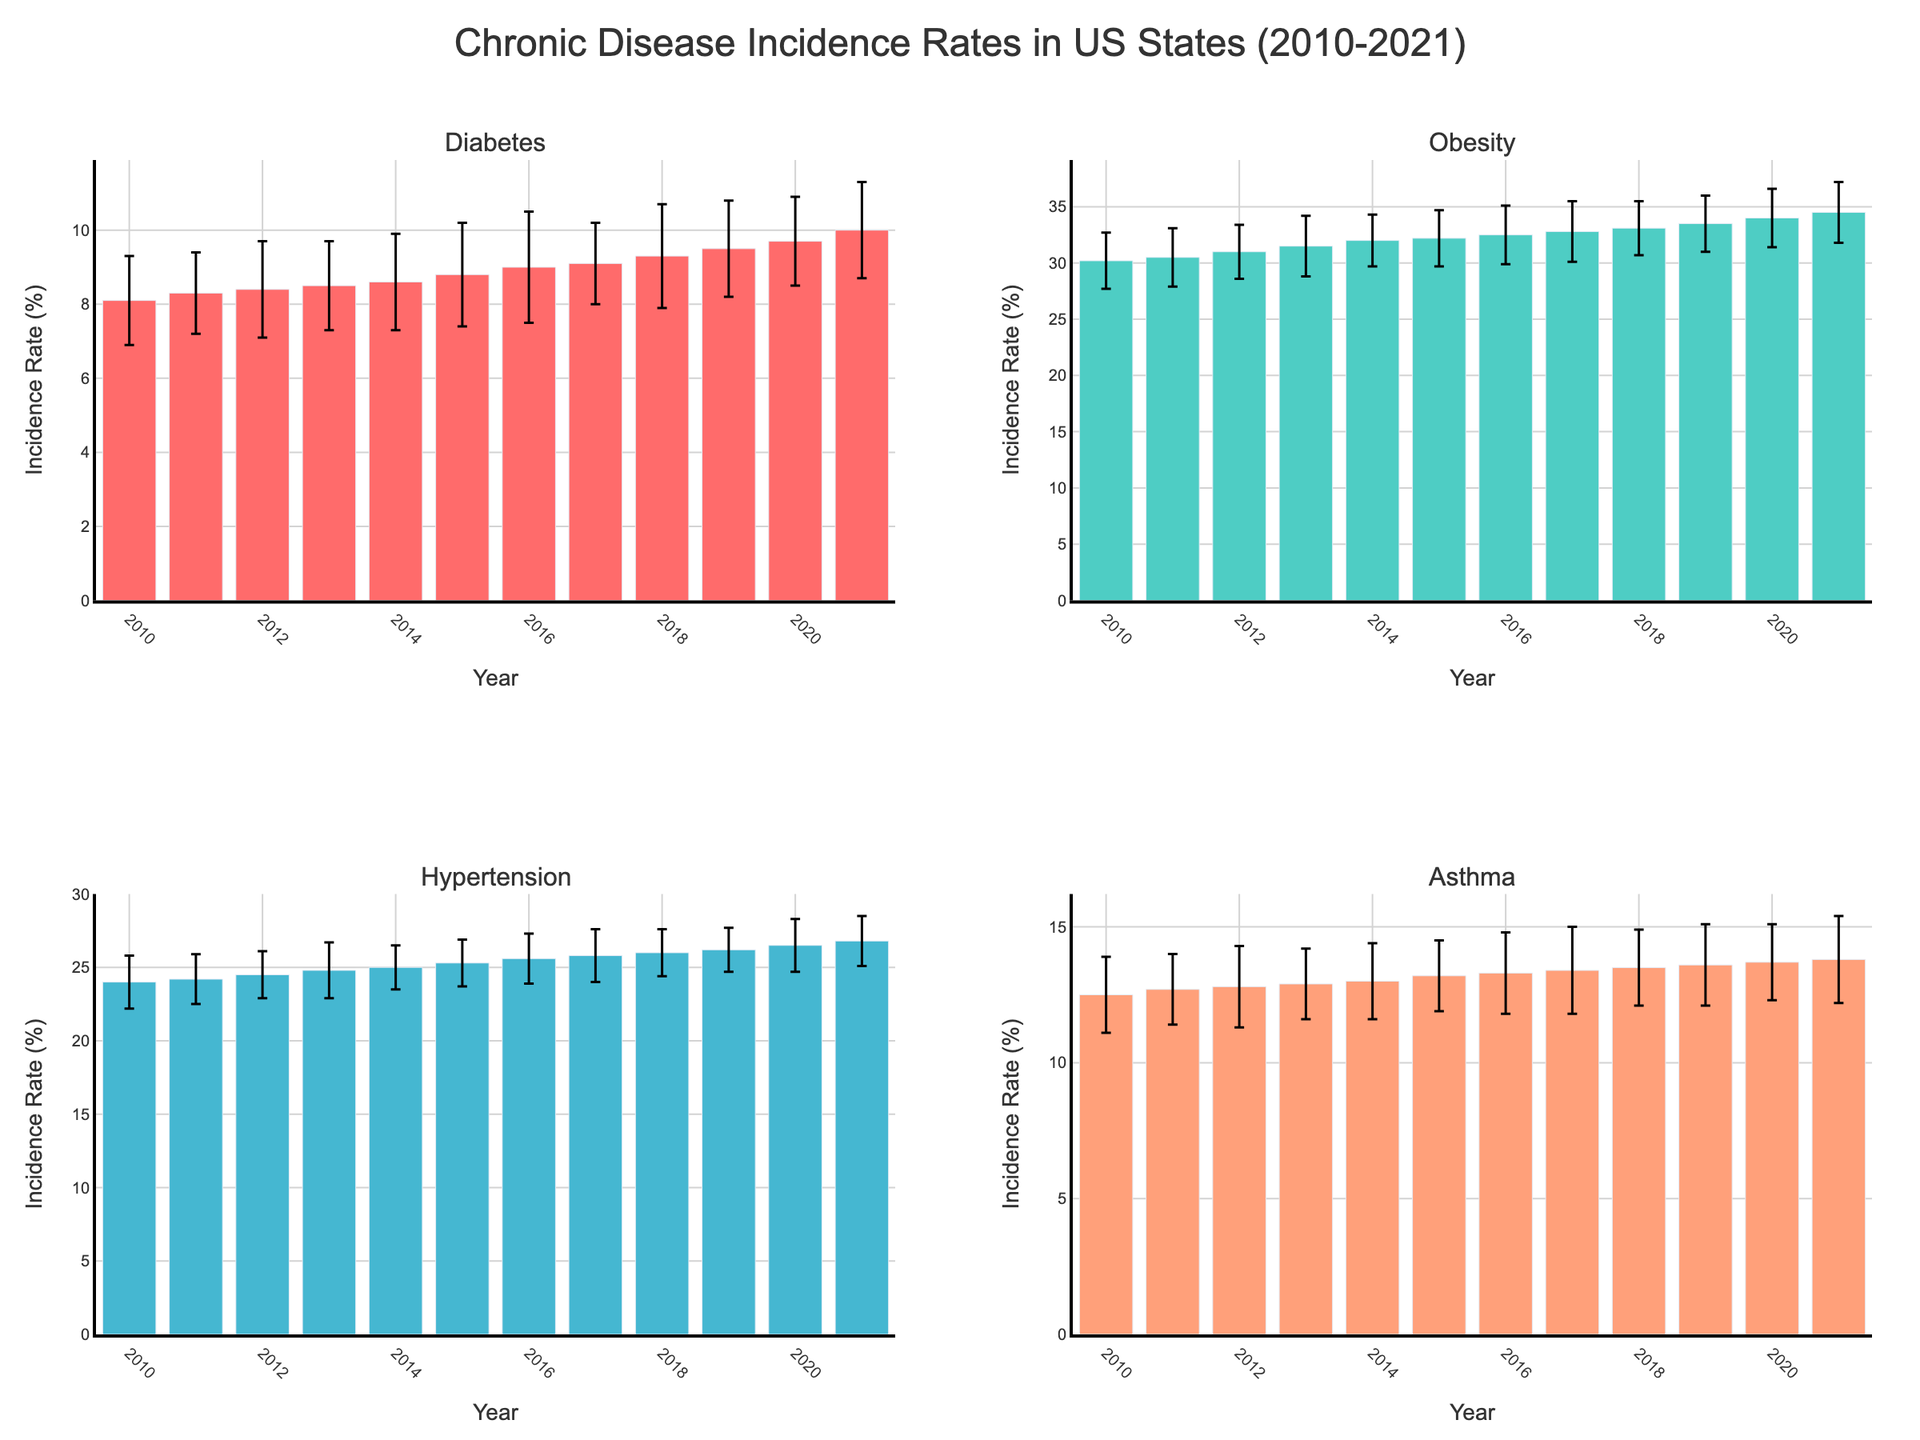What are the chronic diseases shown in the figure? The subplot titles mention Diabetes, Obesity, Hypertension, and Asthma, which are the chronic diseases displayed.
Answer: Diabetes, Obesity, Hypertension, Asthma Which state has the highest incidence rate of its chronic disease in 2021? From the figure, we see bars representing the incidence rates for 2021 for each chronic disease per state. Texas (Obesity) has the highest rate with 34.5%.
Answer: Texas What is the average incidence rate of Diabetes in California over the decade? The incidence rates for Diabetes in California are provided for each year from 2010 to 2021. Summing these rates (8.1 + 8.3 + 8.4 + 8.5 + 8.6 + 8.8 + 9.0 + 9.1 + 9.3 + 9.5 + 9.7 + 10.0) gives 107.3. Dividing by the number of years (12) gives an average of approximately 8.9.
Answer: 8.9 Which state shows the most variability in the incidence rate of its chronic disease? By comparing the error bars across all subplots, Texas (Obesity) consistently shows larger error bars (around 2.4 to 2.7) compared to other states, indicating more variability.
Answer: Texas How much did the incidence rate of Hypertension in Florida increase from 2010 to 2021? The incidence rate for Hypertension in Florida in 2010 is 24.0%. In 2021, it is 26.8%. The increase is 26.8 - 24.0 = 2.8 percentage points.
Answer: 2.8 percentage points Which chronic disease incidence rate in New York shows the smallest error in 2013? By examining the error bars for Asthma in New York, we see in 2013 it has an error bar with a value of 1.3, which is smaller or equal compared to other years.
Answer: Asthma in 2013 In which year did Texas reach a 33% incidence rate of Obesity? By looking at the Texas Obesity subplot, we see that the Obesity incidence rate reaches 33.1% in the year 2018.
Answer: 2018 Compare the Diabetes incidence rate in California in 2015 and 2020. Which was higher and by how much? The incidence rate of Diabetes in California in 2015 was 8.8%, and in 2020 it was 9.7%. The rate in 2020 was higher by 9.7 - 8.8 = 0.9%.
Answer: 2020 by 0.9% What’s the trend of incidence rates for Asthma in New York from 2010 to 2021? Observing the bars for Asthma in New York, the incidence rate increases gradually each year from 12.5% in 2010 to 13.8% in 2021.
Answer: Increasing trend 